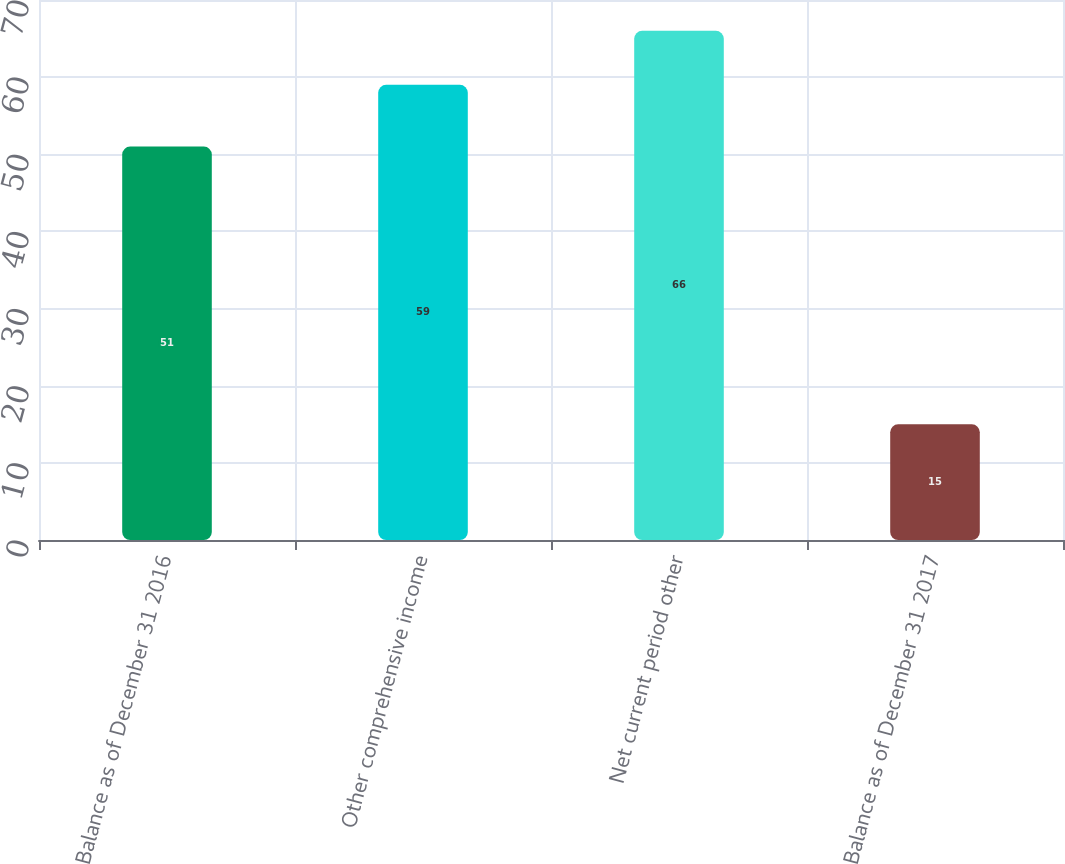Convert chart. <chart><loc_0><loc_0><loc_500><loc_500><bar_chart><fcel>Balance as of December 31 2016<fcel>Other comprehensive income<fcel>Net current period other<fcel>Balance as of December 31 2017<nl><fcel>51<fcel>59<fcel>66<fcel>15<nl></chart> 